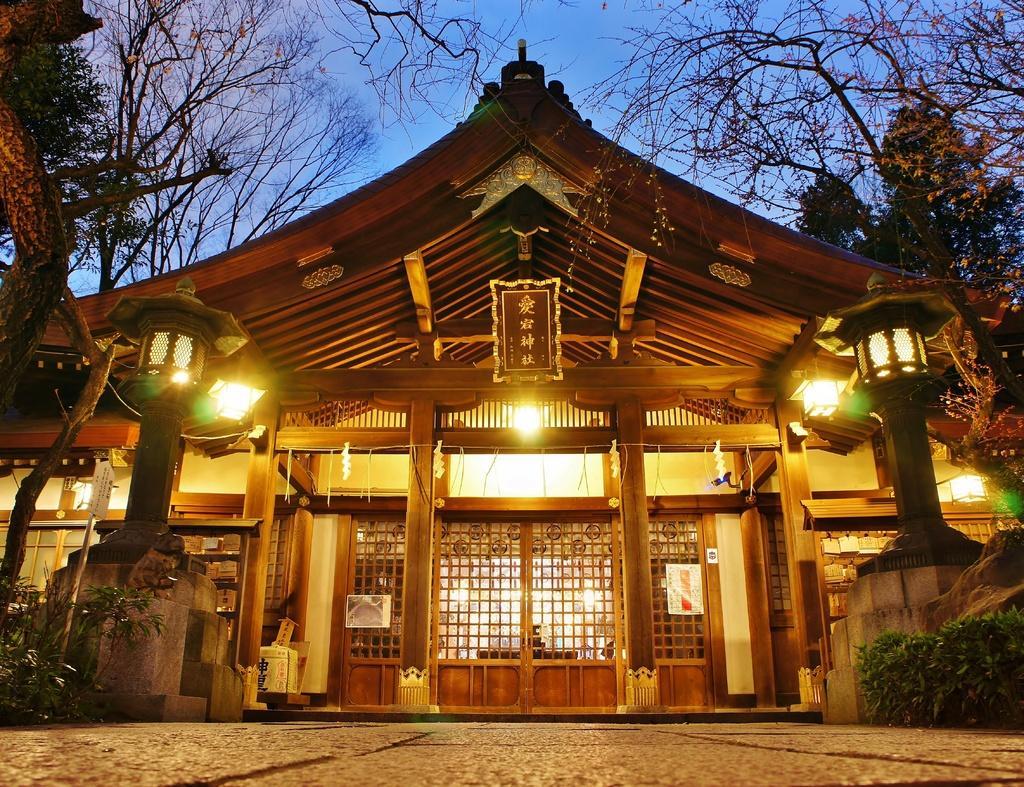Can you describe this image briefly? In this image we can see one house, two lights attached to the pillars, some decorative items attached to the house, some lights attached to the ceiling, some objects in the house, one board with text attached to the house, one poster with an image, one poster with text attached to the house near the door, one object attached to the house, some objects on the surface of the floor, one board with text attached to the pole, some trees and plants on the ground. At the top there is the sky. 